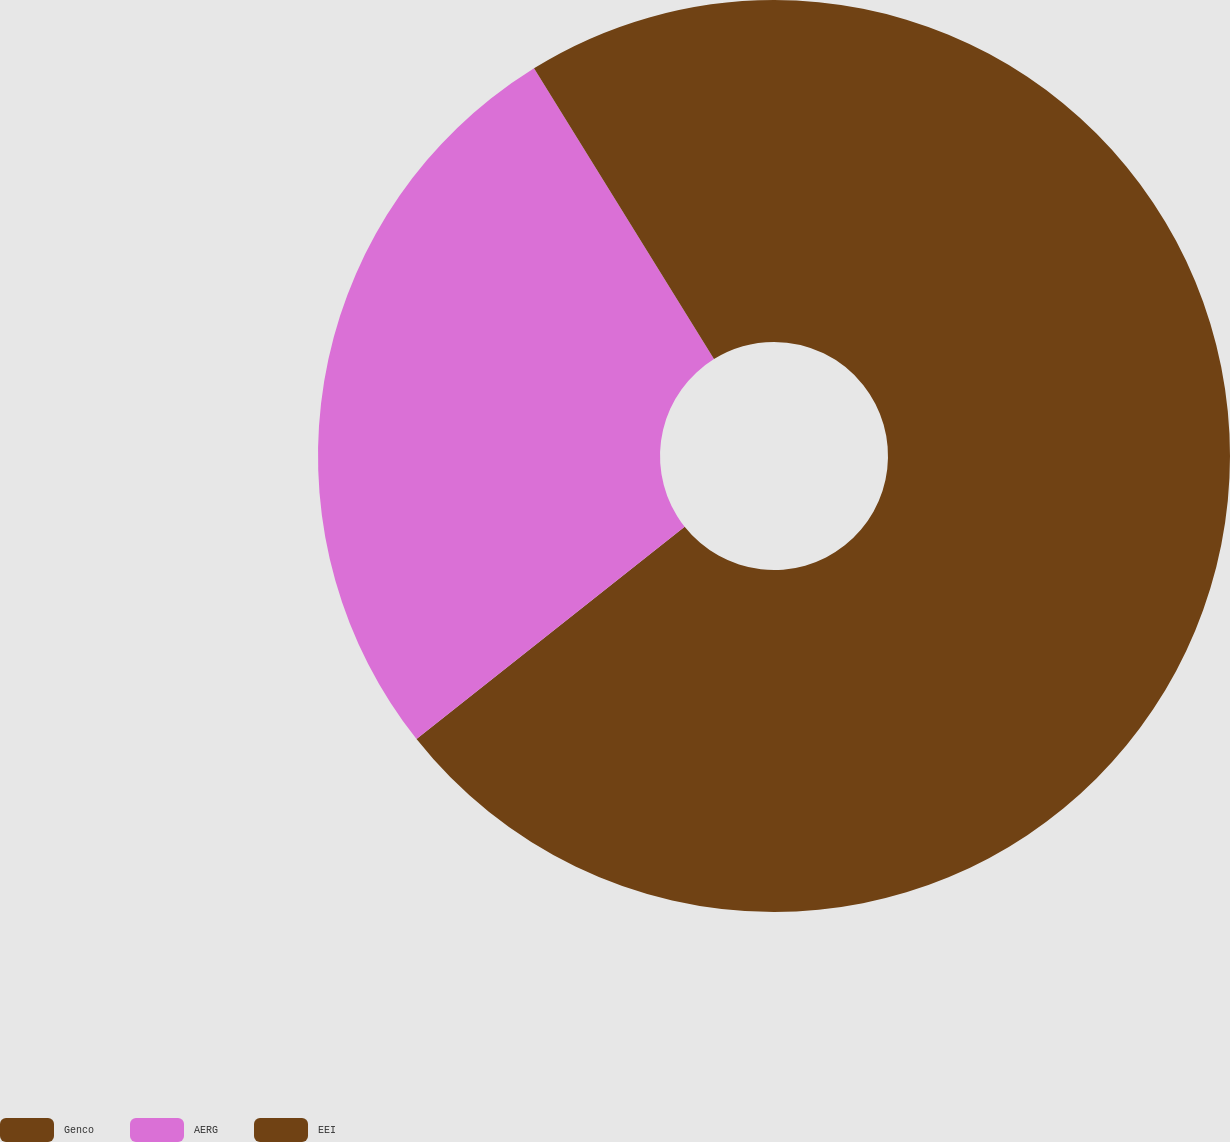<chart> <loc_0><loc_0><loc_500><loc_500><pie_chart><fcel>Genco<fcel>AERG<fcel>EEI<nl><fcel>64.34%<fcel>26.84%<fcel>8.82%<nl></chart> 